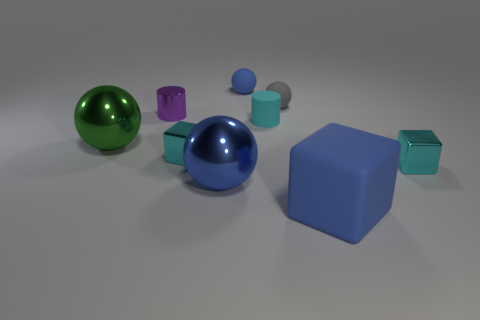Subtract all cylinders. How many objects are left? 7 Subtract all small gray rubber objects. Subtract all small matte cylinders. How many objects are left? 7 Add 7 big green spheres. How many big green spheres are left? 8 Add 1 red cylinders. How many red cylinders exist? 1 Subtract 0 brown cylinders. How many objects are left? 9 